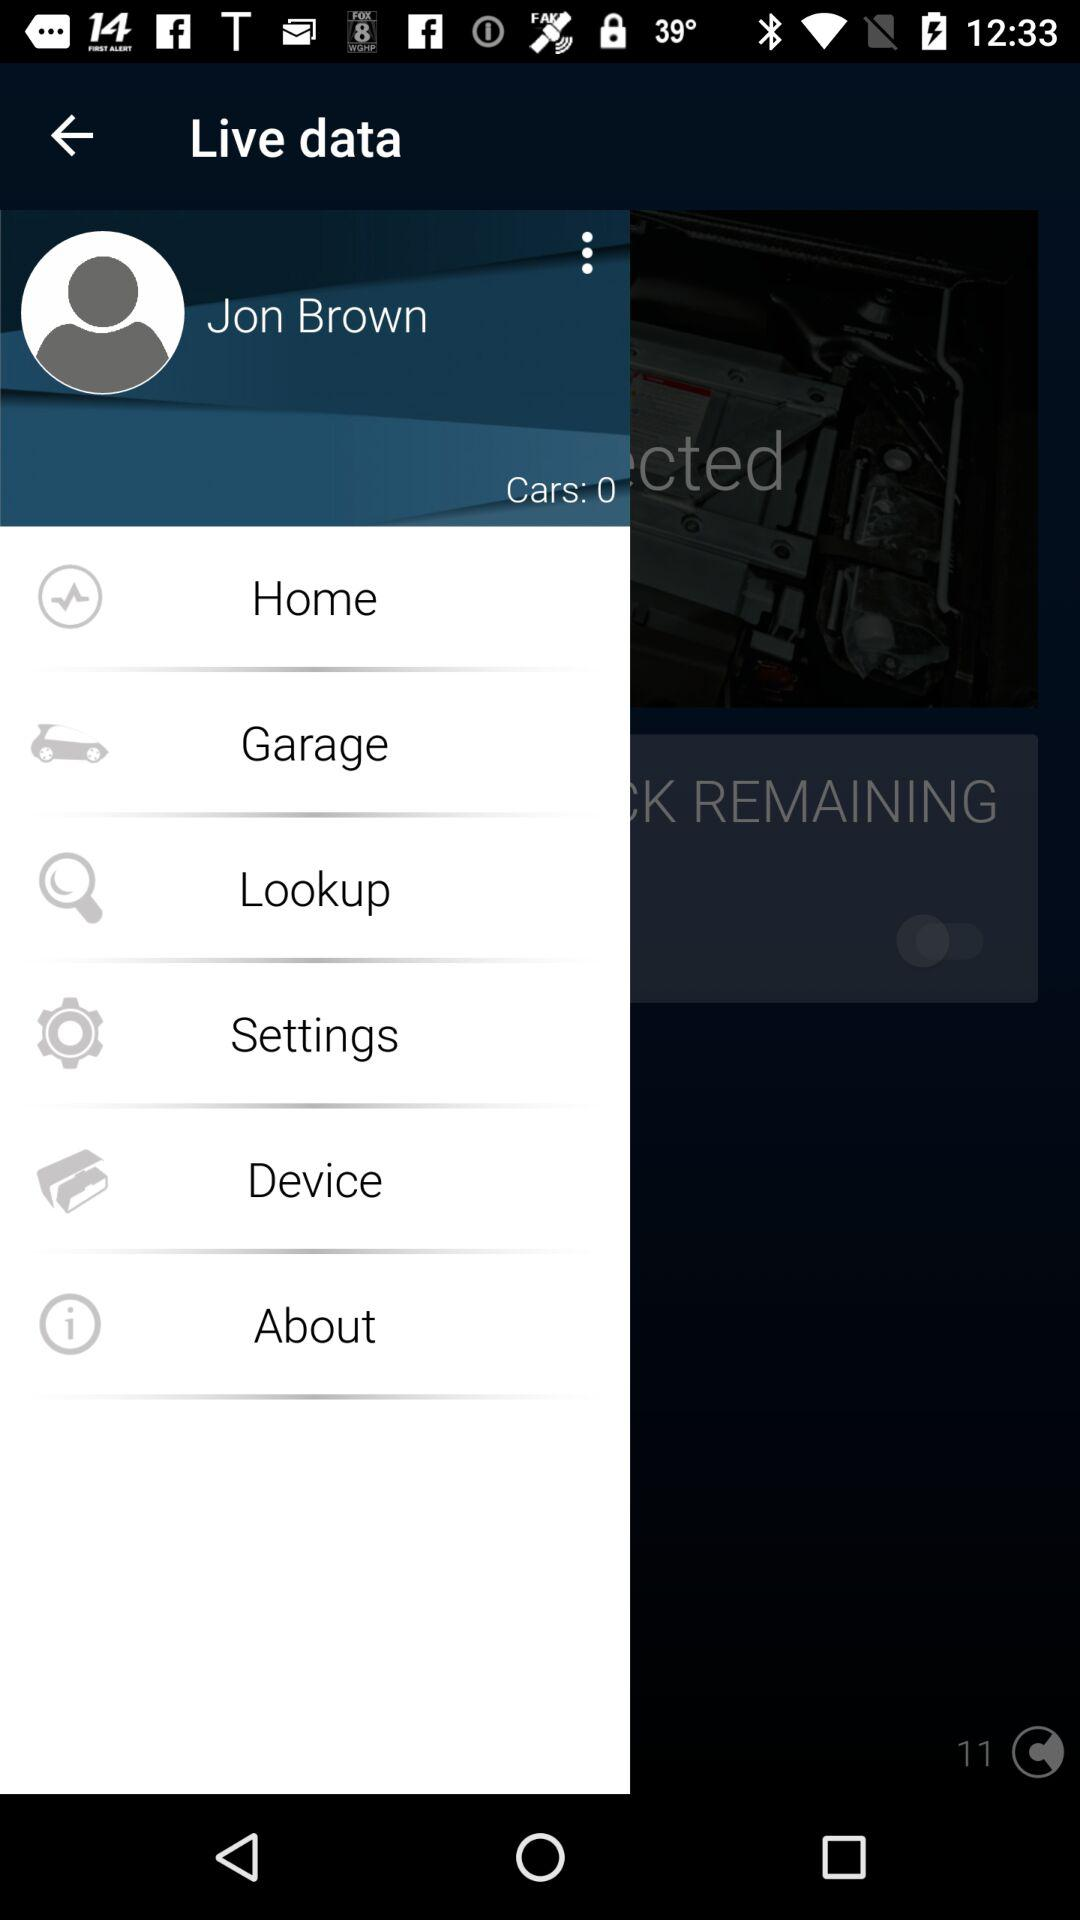What type of data is shown? The type of data that is shown is Live. 